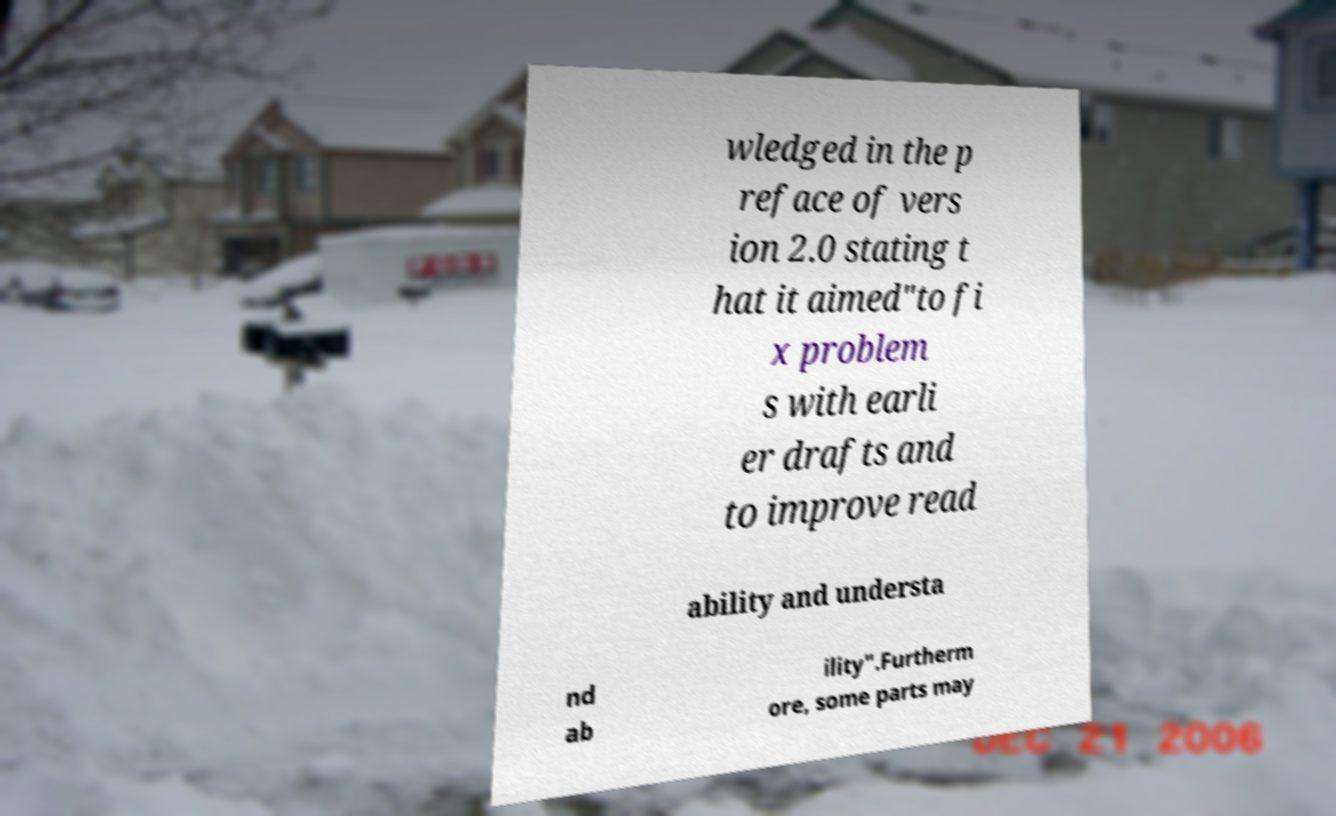Can you accurately transcribe the text from the provided image for me? wledged in the p reface of vers ion 2.0 stating t hat it aimed"to fi x problem s with earli er drafts and to improve read ability and understa nd ab ility".Furtherm ore, some parts may 